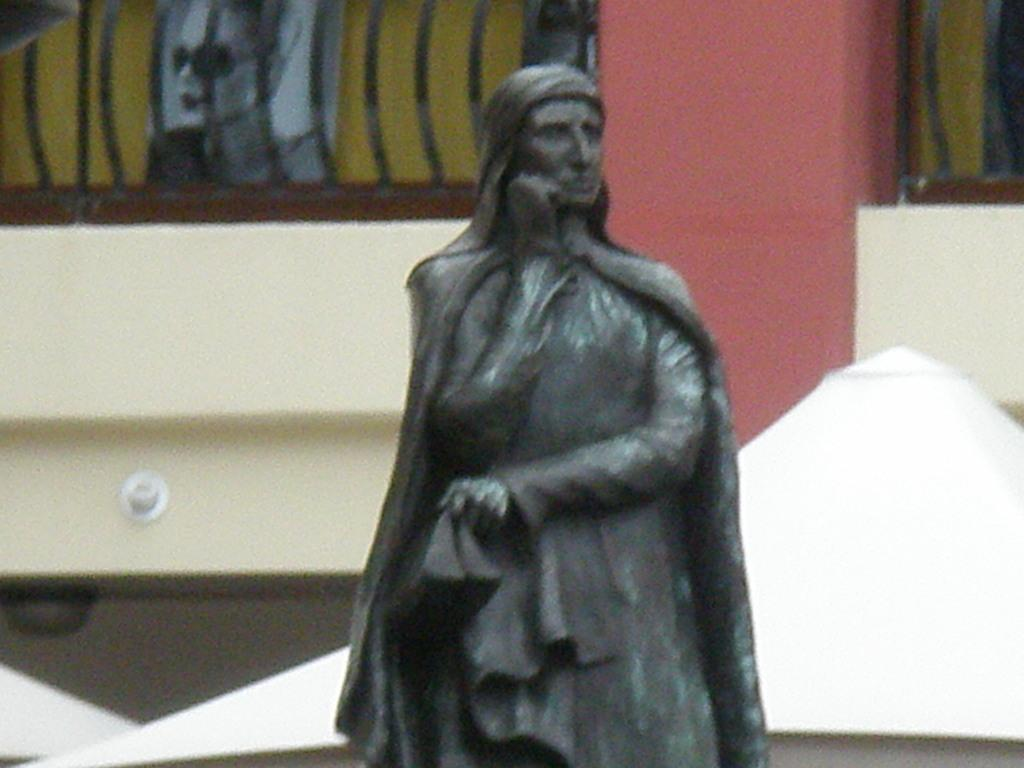What is the main subject in the image? There is a statue of a woman in the image. What can be seen in the background of the image? There is a red color pillar, a fence, a wall, a poster, and other objects in the background. Can you describe the red color pillar in the background? Yes, it is a red color pillar in the background. What type of cheese is being shaken by the porter in the image? There is no porter, cheese, or shaking activity present in the image. 